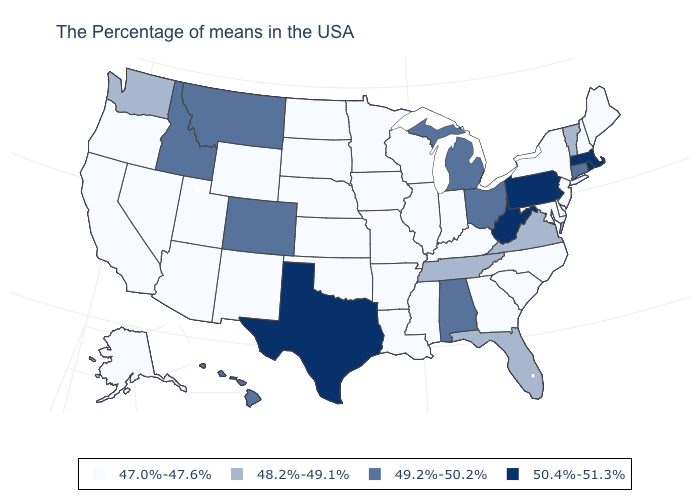What is the value of Colorado?
Keep it brief. 49.2%-50.2%. What is the value of Pennsylvania?
Be succinct. 50.4%-51.3%. How many symbols are there in the legend?
Keep it brief. 4. Does Texas have the highest value in the USA?
Keep it brief. Yes. Among the states that border Michigan , does Ohio have the lowest value?
Quick response, please. No. What is the value of Nebraska?
Be succinct. 47.0%-47.6%. Does Illinois have the same value as Idaho?
Quick response, please. No. Name the states that have a value in the range 47.0%-47.6%?
Short answer required. Maine, New Hampshire, New York, New Jersey, Delaware, Maryland, North Carolina, South Carolina, Georgia, Kentucky, Indiana, Wisconsin, Illinois, Mississippi, Louisiana, Missouri, Arkansas, Minnesota, Iowa, Kansas, Nebraska, Oklahoma, South Dakota, North Dakota, Wyoming, New Mexico, Utah, Arizona, Nevada, California, Oregon, Alaska. What is the value of North Dakota?
Quick response, please. 47.0%-47.6%. Is the legend a continuous bar?
Write a very short answer. No. What is the lowest value in the USA?
Be succinct. 47.0%-47.6%. What is the highest value in the Northeast ?
Short answer required. 50.4%-51.3%. Does Virginia have the lowest value in the USA?
Give a very brief answer. No. Which states have the highest value in the USA?
Short answer required. Massachusetts, Rhode Island, Pennsylvania, West Virginia, Texas. What is the value of California?
Be succinct. 47.0%-47.6%. 